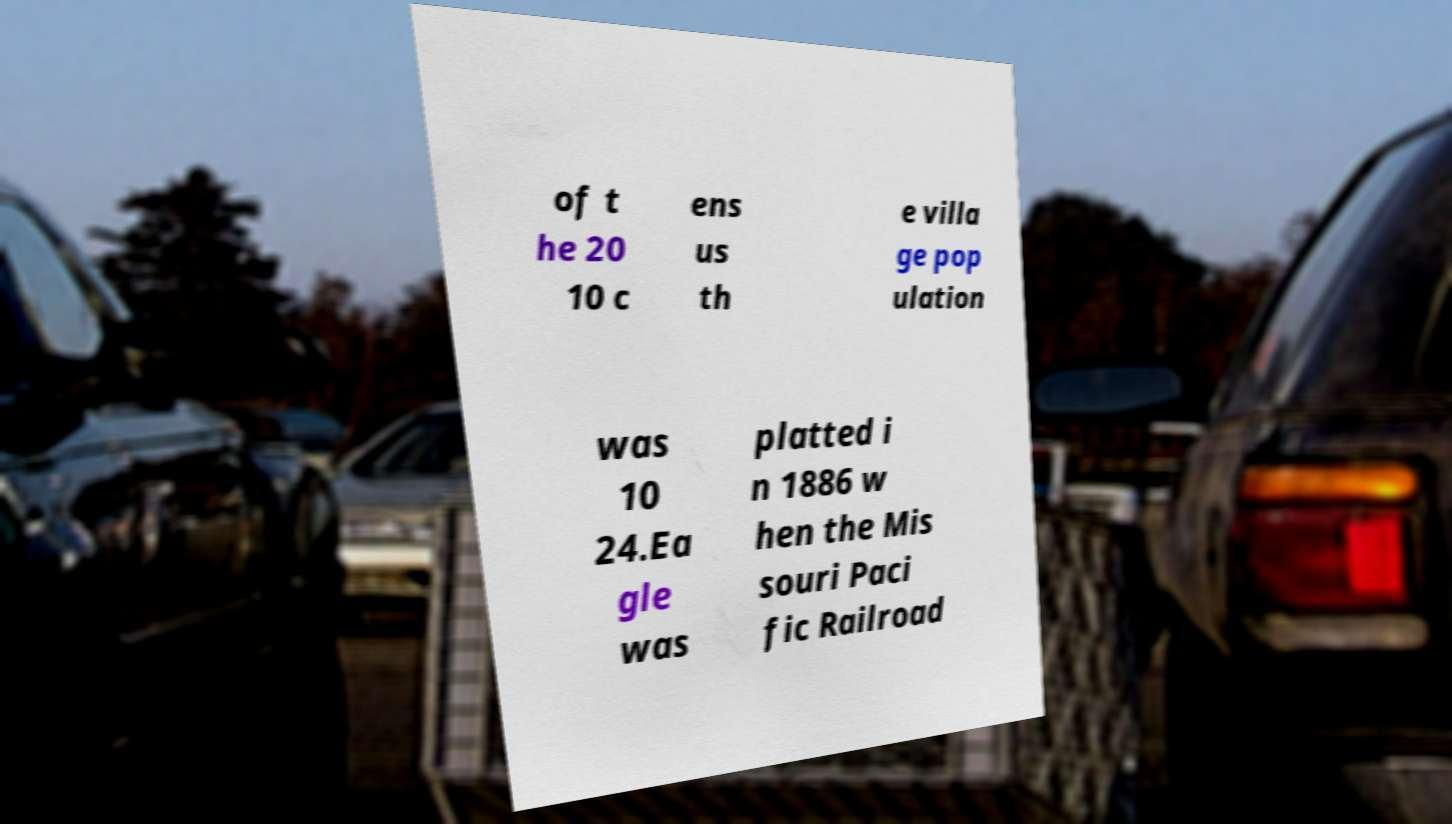For documentation purposes, I need the text within this image transcribed. Could you provide that? of t he 20 10 c ens us th e villa ge pop ulation was 10 24.Ea gle was platted i n 1886 w hen the Mis souri Paci fic Railroad 